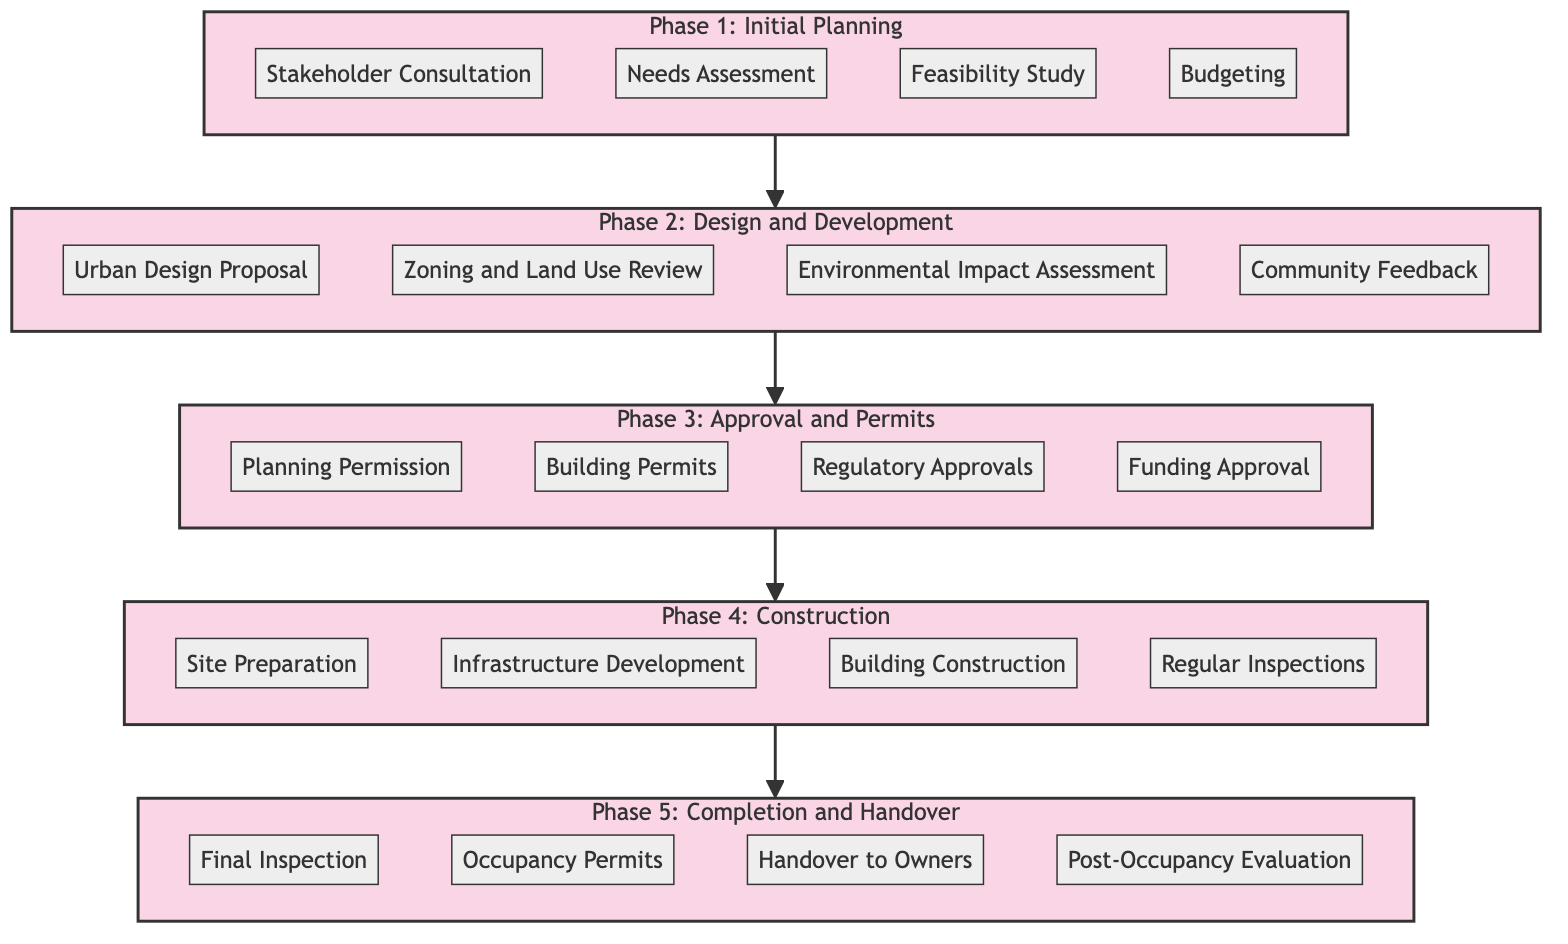What are the elements included in Phase 1? Phase 1, titled "Initial Planning," includes four elements: Stakeholder Consultation, Needs Assessment, Feasibility Study, and Budgeting. These elements can be directly read from the diagram under the corresponding phase.
Answer: Stakeholder Consultation, Needs Assessment, Feasibility Study, Budgeting How many phases are there in the urban renewal project? The diagram shows five distinct phases: Initial Planning, Design and Development, Approval and Permits, Construction, and Completion and Handover. This count can be derived from the number of phase labels in the block diagram.
Answer: Five What comes after Phase 2 in the project? According to the flow of the diagram, Phase 2 titled "Design and Development" is followed directly by Phase 3, which is "Approval and Permits." This relationship is indicated by the arrows directing the flow from one phase to the next.
Answer: Approval and Permits What is the final element of Phase 5? The last element in Phase 5, labeled "Completion and Handover," is "Post-Occupancy Evaluation." This can be located by examining the elements listed in the final phase of the block diagram.
Answer: Post-Occupancy Evaluation Which phase involves the Environmental Impact Assessment? The Environmental Impact Assessment is specifically listed as one of the elements within Phase 2, which is "Design and Development." By looking at the elements of each phase, this can be confirmed.
Answer: Design and Development How many elements are there in Phase 4? Phase 4, titled "Construction," consists of four elements: Site Preparation, Infrastructure Development, Building Construction, and Regular Inspections. This can be concluded by counting the elements displayed in the corresponding phase in the diagram.
Answer: Four What is the first element of Phase 3? The first element of Phase 3, titled "Approval and Permits," is "Planning Permission." This can be easily identified by looking at the order of elements listed under that specific phase in the diagram.
Answer: Planning Permission What phase directly leads to the construction activities? The "Construction" phase, which is Phase 4, directly follows the "Approval and Permits" phase, indicating that activities related to construction commence after obtaining necessary approvals. This relationship is shown in the sequential flow of the diagram.
Answer: Construction 